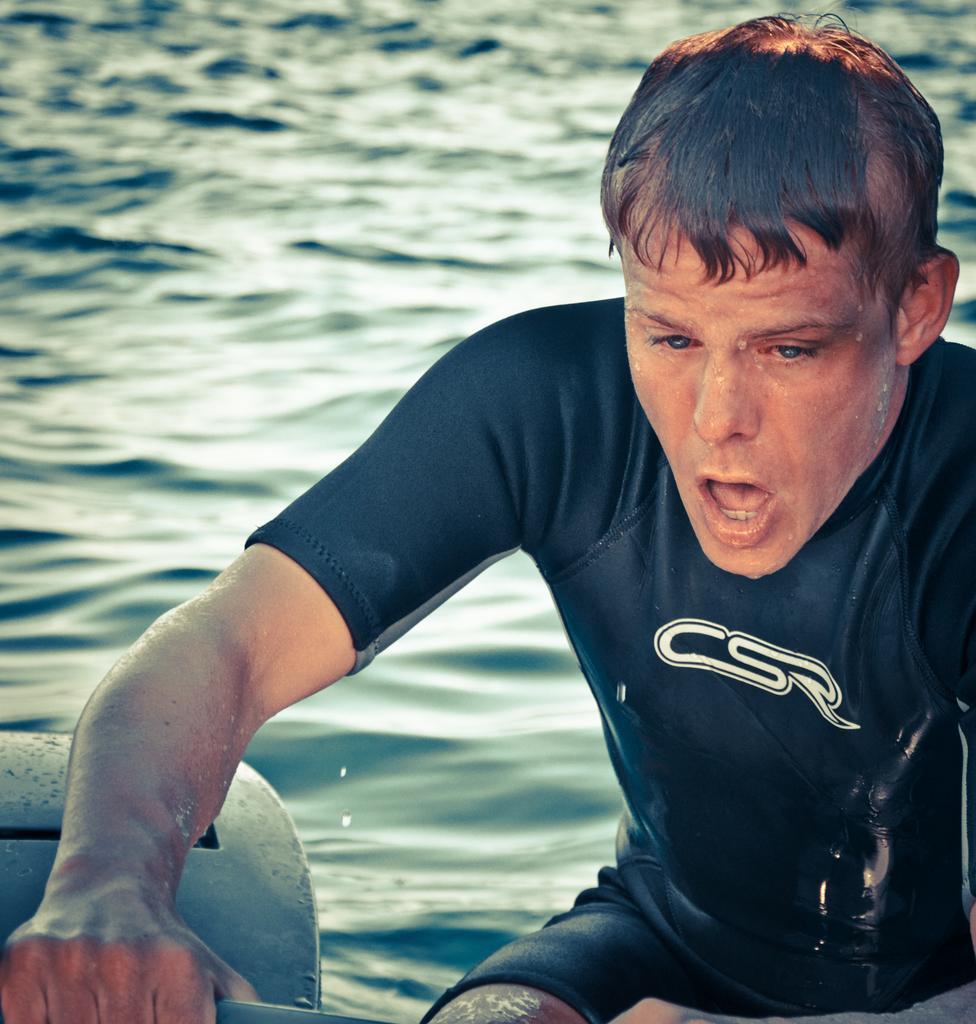Please provide a concise description of this image. In this image we can see a person holding in the hand. In the background there is water. Near to him there is an object. 